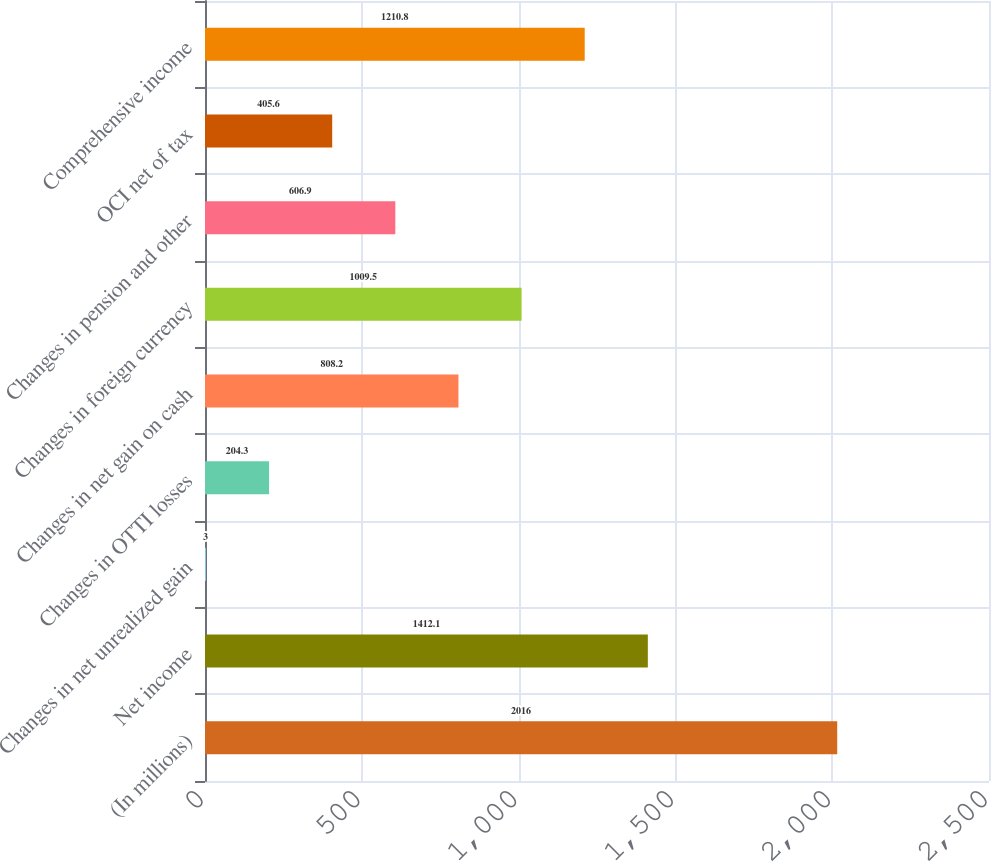<chart> <loc_0><loc_0><loc_500><loc_500><bar_chart><fcel>(In millions)<fcel>Net income<fcel>Changes in net unrealized gain<fcel>Changes in OTTI losses<fcel>Changes in net gain on cash<fcel>Changes in foreign currency<fcel>Changes in pension and other<fcel>OCI net of tax<fcel>Comprehensive income<nl><fcel>2016<fcel>1412.1<fcel>3<fcel>204.3<fcel>808.2<fcel>1009.5<fcel>606.9<fcel>405.6<fcel>1210.8<nl></chart> 